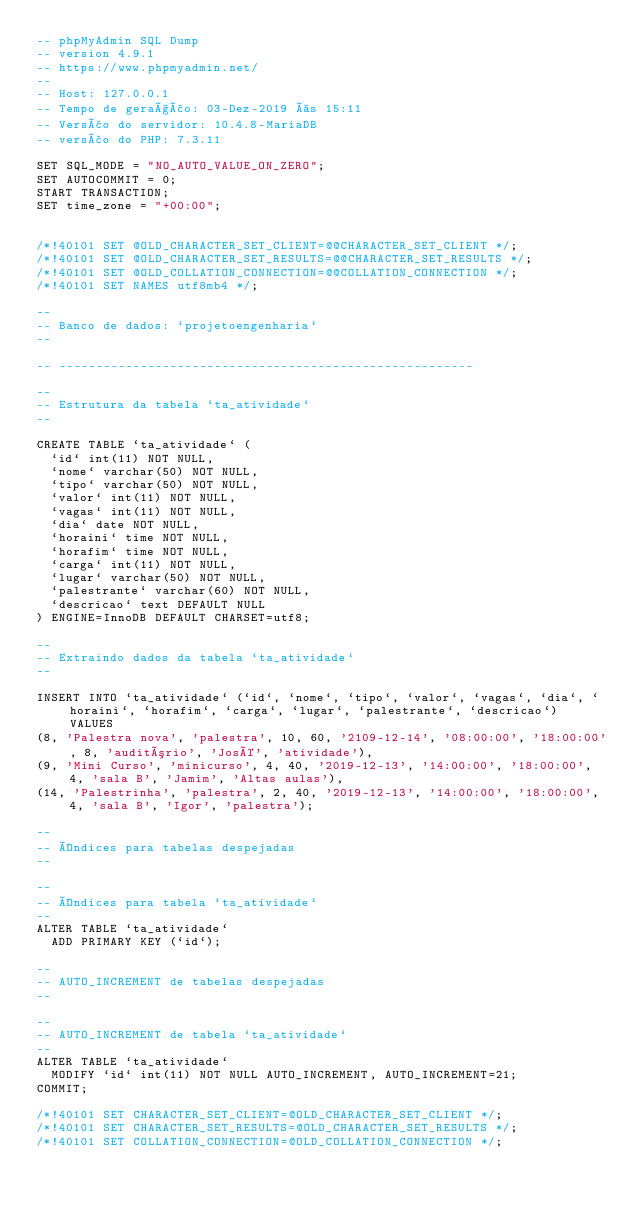<code> <loc_0><loc_0><loc_500><loc_500><_SQL_>-- phpMyAdmin SQL Dump
-- version 4.9.1
-- https://www.phpmyadmin.net/
--
-- Host: 127.0.0.1
-- Tempo de geração: 03-Dez-2019 às 15:11
-- Versão do servidor: 10.4.8-MariaDB
-- versão do PHP: 7.3.11

SET SQL_MODE = "NO_AUTO_VALUE_ON_ZERO";
SET AUTOCOMMIT = 0;
START TRANSACTION;
SET time_zone = "+00:00";


/*!40101 SET @OLD_CHARACTER_SET_CLIENT=@@CHARACTER_SET_CLIENT */;
/*!40101 SET @OLD_CHARACTER_SET_RESULTS=@@CHARACTER_SET_RESULTS */;
/*!40101 SET @OLD_COLLATION_CONNECTION=@@COLLATION_CONNECTION */;
/*!40101 SET NAMES utf8mb4 */;

--
-- Banco de dados: `projetoengenharia`
--

-- --------------------------------------------------------

--
-- Estrutura da tabela `ta_atividade`
--

CREATE TABLE `ta_atividade` (
  `id` int(11) NOT NULL,
  `nome` varchar(50) NOT NULL,
  `tipo` varchar(50) NOT NULL,
  `valor` int(11) NOT NULL,
  `vagas` int(11) NOT NULL,
  `dia` date NOT NULL,
  `horaini` time NOT NULL,
  `horafim` time NOT NULL,
  `carga` int(11) NOT NULL,
  `lugar` varchar(50) NOT NULL,
  `palestrante` varchar(60) NOT NULL,
  `descricao` text DEFAULT NULL
) ENGINE=InnoDB DEFAULT CHARSET=utf8;

--
-- Extraindo dados da tabela `ta_atividade`
--

INSERT INTO `ta_atividade` (`id`, `nome`, `tipo`, `valor`, `vagas`, `dia`, `horaini`, `horafim`, `carga`, `lugar`, `palestrante`, `descricao`) VALUES
(8, 'Palestra nova', 'palestra', 10, 60, '2109-12-14', '08:00:00', '18:00:00', 8, 'auditório', 'José', 'atividade'),
(9, 'Mini Curso', 'minicurso', 4, 40, '2019-12-13', '14:00:00', '18:00:00', 4, 'sala B', 'Jamim', 'Altas aulas'),
(14, 'Palestrinha', 'palestra', 2, 40, '2019-12-13', '14:00:00', '18:00:00', 4, 'sala B', 'Igor', 'palestra');

--
-- Índices para tabelas despejadas
--

--
-- Índices para tabela `ta_atividade`
--
ALTER TABLE `ta_atividade`
  ADD PRIMARY KEY (`id`);

--
-- AUTO_INCREMENT de tabelas despejadas
--

--
-- AUTO_INCREMENT de tabela `ta_atividade`
--
ALTER TABLE `ta_atividade`
  MODIFY `id` int(11) NOT NULL AUTO_INCREMENT, AUTO_INCREMENT=21;
COMMIT;

/*!40101 SET CHARACTER_SET_CLIENT=@OLD_CHARACTER_SET_CLIENT */;
/*!40101 SET CHARACTER_SET_RESULTS=@OLD_CHARACTER_SET_RESULTS */;
/*!40101 SET COLLATION_CONNECTION=@OLD_COLLATION_CONNECTION */;
</code> 